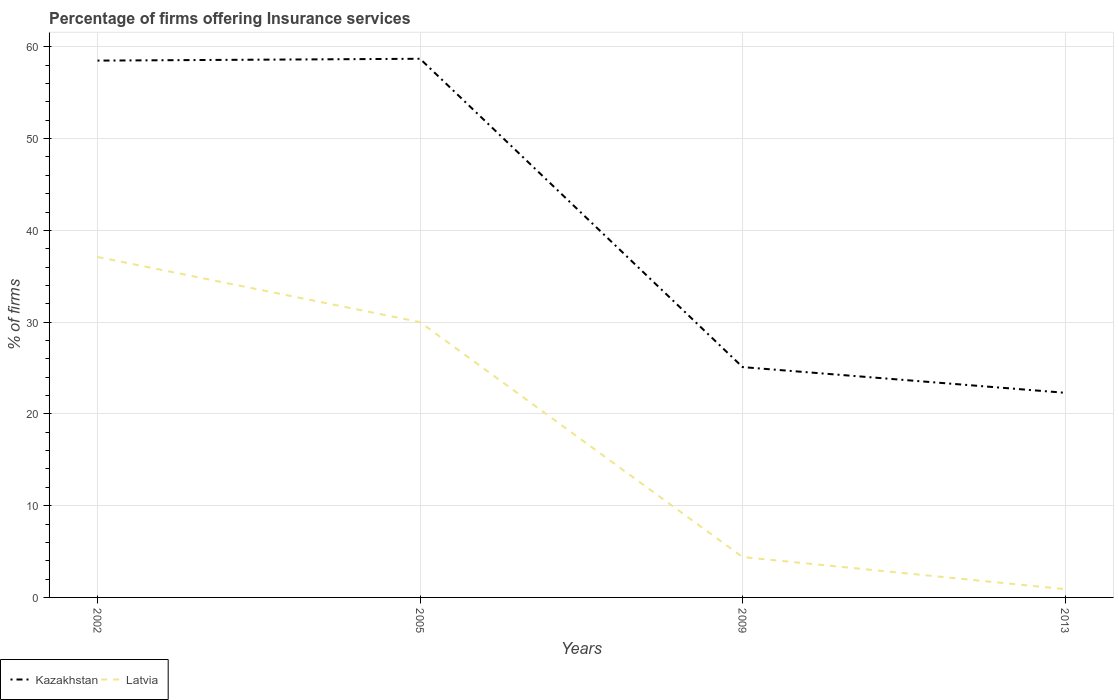How many different coloured lines are there?
Offer a very short reply. 2. Does the line corresponding to Kazakhstan intersect with the line corresponding to Latvia?
Offer a terse response. No. Is the number of lines equal to the number of legend labels?
Give a very brief answer. Yes. In which year was the percentage of firms offering insurance services in Latvia maximum?
Keep it short and to the point. 2013. What is the total percentage of firms offering insurance services in Kazakhstan in the graph?
Offer a terse response. 33.6. What is the difference between the highest and the second highest percentage of firms offering insurance services in Kazakhstan?
Provide a short and direct response. 36.4. What is the difference between the highest and the lowest percentage of firms offering insurance services in Kazakhstan?
Provide a succinct answer. 2. How many years are there in the graph?
Your answer should be very brief. 4. What is the difference between two consecutive major ticks on the Y-axis?
Give a very brief answer. 10. Are the values on the major ticks of Y-axis written in scientific E-notation?
Make the answer very short. No. How many legend labels are there?
Make the answer very short. 2. What is the title of the graph?
Provide a short and direct response. Percentage of firms offering Insurance services. What is the label or title of the Y-axis?
Offer a terse response. % of firms. What is the % of firms of Kazakhstan in 2002?
Offer a terse response. 58.5. What is the % of firms of Latvia in 2002?
Make the answer very short. 37.1. What is the % of firms of Kazakhstan in 2005?
Your response must be concise. 58.7. What is the % of firms of Latvia in 2005?
Your answer should be compact. 30. What is the % of firms of Kazakhstan in 2009?
Keep it short and to the point. 25.1. What is the % of firms of Latvia in 2009?
Offer a very short reply. 4.4. What is the % of firms of Kazakhstan in 2013?
Keep it short and to the point. 22.3. Across all years, what is the maximum % of firms of Kazakhstan?
Your answer should be compact. 58.7. Across all years, what is the maximum % of firms in Latvia?
Provide a succinct answer. 37.1. Across all years, what is the minimum % of firms of Kazakhstan?
Keep it short and to the point. 22.3. Across all years, what is the minimum % of firms in Latvia?
Offer a very short reply. 0.9. What is the total % of firms in Kazakhstan in the graph?
Ensure brevity in your answer.  164.6. What is the total % of firms of Latvia in the graph?
Give a very brief answer. 72.4. What is the difference between the % of firms of Kazakhstan in 2002 and that in 2005?
Provide a succinct answer. -0.2. What is the difference between the % of firms of Latvia in 2002 and that in 2005?
Offer a very short reply. 7.1. What is the difference between the % of firms in Kazakhstan in 2002 and that in 2009?
Make the answer very short. 33.4. What is the difference between the % of firms in Latvia in 2002 and that in 2009?
Provide a short and direct response. 32.7. What is the difference between the % of firms of Kazakhstan in 2002 and that in 2013?
Keep it short and to the point. 36.2. What is the difference between the % of firms of Latvia in 2002 and that in 2013?
Make the answer very short. 36.2. What is the difference between the % of firms of Kazakhstan in 2005 and that in 2009?
Provide a short and direct response. 33.6. What is the difference between the % of firms of Latvia in 2005 and that in 2009?
Keep it short and to the point. 25.6. What is the difference between the % of firms of Kazakhstan in 2005 and that in 2013?
Keep it short and to the point. 36.4. What is the difference between the % of firms of Latvia in 2005 and that in 2013?
Give a very brief answer. 29.1. What is the difference between the % of firms of Kazakhstan in 2002 and the % of firms of Latvia in 2009?
Give a very brief answer. 54.1. What is the difference between the % of firms of Kazakhstan in 2002 and the % of firms of Latvia in 2013?
Your answer should be compact. 57.6. What is the difference between the % of firms of Kazakhstan in 2005 and the % of firms of Latvia in 2009?
Your answer should be compact. 54.3. What is the difference between the % of firms of Kazakhstan in 2005 and the % of firms of Latvia in 2013?
Provide a succinct answer. 57.8. What is the difference between the % of firms in Kazakhstan in 2009 and the % of firms in Latvia in 2013?
Offer a very short reply. 24.2. What is the average % of firms of Kazakhstan per year?
Your answer should be compact. 41.15. What is the average % of firms of Latvia per year?
Make the answer very short. 18.1. In the year 2002, what is the difference between the % of firms in Kazakhstan and % of firms in Latvia?
Offer a terse response. 21.4. In the year 2005, what is the difference between the % of firms in Kazakhstan and % of firms in Latvia?
Give a very brief answer. 28.7. In the year 2009, what is the difference between the % of firms of Kazakhstan and % of firms of Latvia?
Make the answer very short. 20.7. In the year 2013, what is the difference between the % of firms of Kazakhstan and % of firms of Latvia?
Offer a terse response. 21.4. What is the ratio of the % of firms in Latvia in 2002 to that in 2005?
Your answer should be compact. 1.24. What is the ratio of the % of firms of Kazakhstan in 2002 to that in 2009?
Your answer should be very brief. 2.33. What is the ratio of the % of firms in Latvia in 2002 to that in 2009?
Offer a very short reply. 8.43. What is the ratio of the % of firms of Kazakhstan in 2002 to that in 2013?
Provide a succinct answer. 2.62. What is the ratio of the % of firms of Latvia in 2002 to that in 2013?
Provide a succinct answer. 41.22. What is the ratio of the % of firms in Kazakhstan in 2005 to that in 2009?
Ensure brevity in your answer.  2.34. What is the ratio of the % of firms of Latvia in 2005 to that in 2009?
Keep it short and to the point. 6.82. What is the ratio of the % of firms in Kazakhstan in 2005 to that in 2013?
Make the answer very short. 2.63. What is the ratio of the % of firms in Latvia in 2005 to that in 2013?
Offer a terse response. 33.33. What is the ratio of the % of firms in Kazakhstan in 2009 to that in 2013?
Offer a very short reply. 1.13. What is the ratio of the % of firms in Latvia in 2009 to that in 2013?
Make the answer very short. 4.89. What is the difference between the highest and the second highest % of firms of Kazakhstan?
Your response must be concise. 0.2. What is the difference between the highest and the lowest % of firms of Kazakhstan?
Give a very brief answer. 36.4. What is the difference between the highest and the lowest % of firms of Latvia?
Keep it short and to the point. 36.2. 